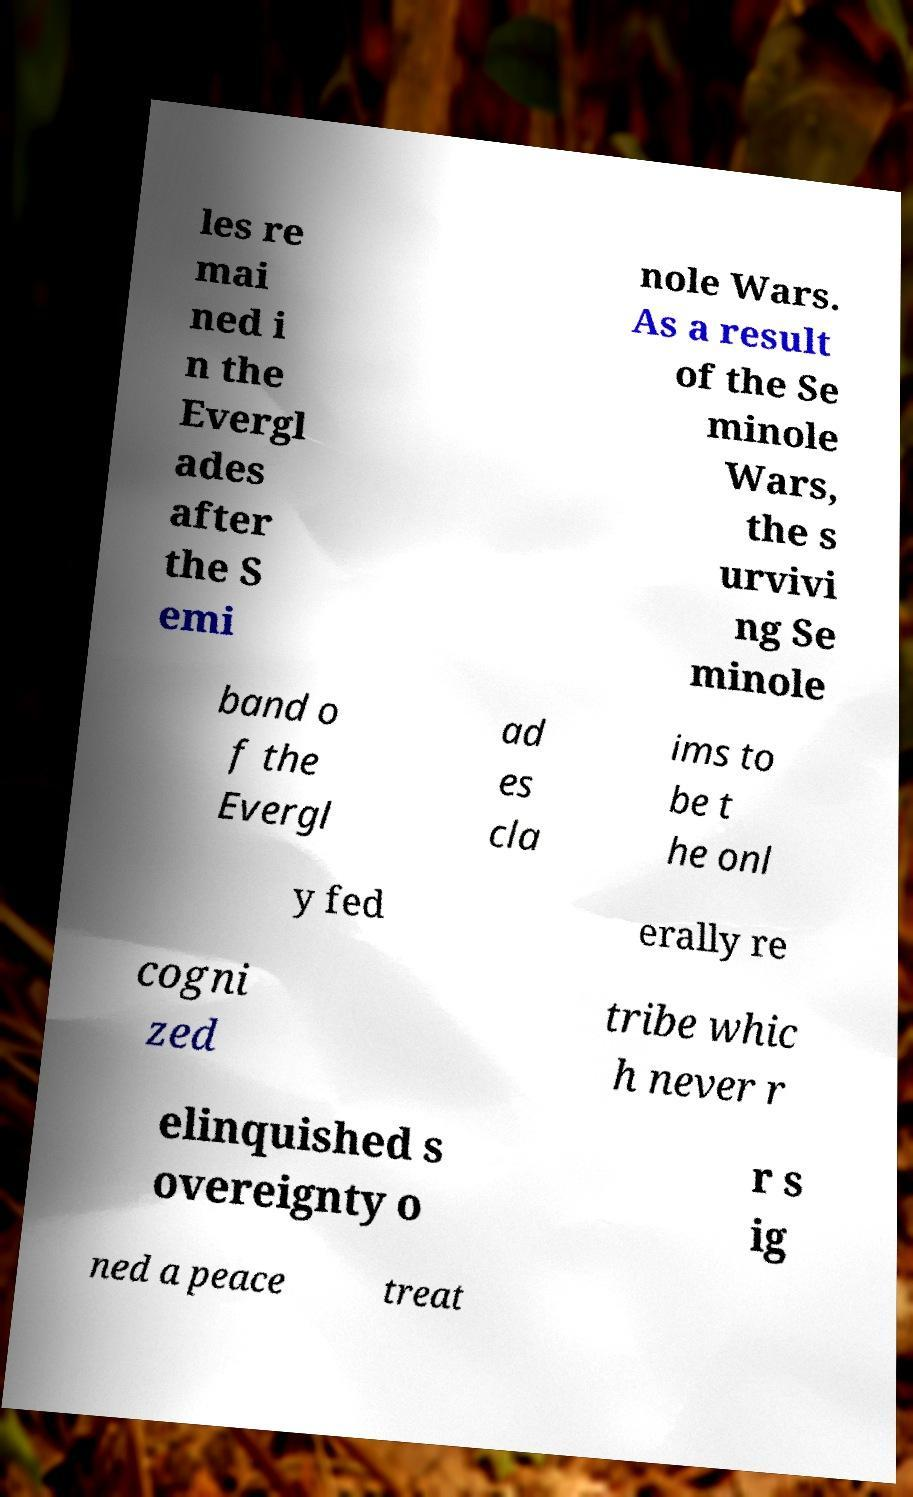I need the written content from this picture converted into text. Can you do that? les re mai ned i n the Evergl ades after the S emi nole Wars. As a result of the Se minole Wars, the s urvivi ng Se minole band o f the Evergl ad es cla ims to be t he onl y fed erally re cogni zed tribe whic h never r elinquished s overeignty o r s ig ned a peace treat 